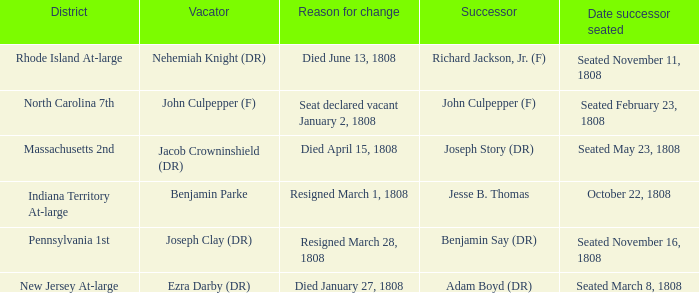Can you parse all the data within this table? {'header': ['District', 'Vacator', 'Reason for change', 'Successor', 'Date successor seated'], 'rows': [['Rhode Island At-large', 'Nehemiah Knight (DR)', 'Died June 13, 1808', 'Richard Jackson, Jr. (F)', 'Seated November 11, 1808'], ['North Carolina 7th', 'John Culpepper (F)', 'Seat declared vacant January 2, 1808', 'John Culpepper (F)', 'Seated February 23, 1808'], ['Massachusetts 2nd', 'Jacob Crowninshield (DR)', 'Died April 15, 1808', 'Joseph Story (DR)', 'Seated May 23, 1808'], ['Indiana Territory At-large', 'Benjamin Parke', 'Resigned March 1, 1808', 'Jesse B. Thomas', 'October 22, 1808'], ['Pennsylvania 1st', 'Joseph Clay (DR)', 'Resigned March 28, 1808', 'Benjamin Say (DR)', 'Seated November 16, 1808'], ['New Jersey At-large', 'Ezra Darby (DR)', 'Died January 27, 1808', 'Adam Boyd (DR)', 'Seated March 8, 1808']]} How many vacators have October 22, 1808 as date successor seated? 1.0. 